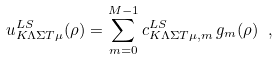<formula> <loc_0><loc_0><loc_500><loc_500>u ^ { L S } _ { K \Lambda \Sigma T \mu } ( \rho ) = \sum _ { m = 0 } ^ { M - 1 } c ^ { L S } _ { K \Lambda \Sigma T \mu , m } \, g _ { m } ( \rho ) \ ,</formula> 